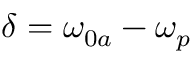<formula> <loc_0><loc_0><loc_500><loc_500>\delta = \omega _ { 0 a } - \omega _ { p }</formula> 